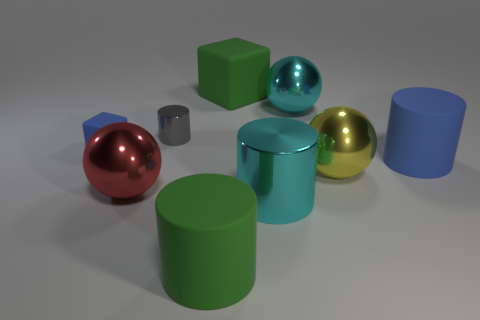There is a blue rubber thing that is right of the tiny cylinder; are there any matte objects that are on the left side of it?
Provide a short and direct response. Yes. What material is the green object that is the same shape as the large blue matte object?
Offer a very short reply. Rubber. Is the number of small cyan metallic balls greater than the number of large yellow things?
Your response must be concise. No. Is the color of the large cube the same as the rubber object that is in front of the yellow thing?
Offer a very short reply. Yes. What color is the big object that is both on the left side of the large metal cylinder and behind the small gray metal thing?
Give a very brief answer. Green. How many other objects are there of the same material as the large yellow object?
Give a very brief answer. 4. Are there fewer green matte cylinders than green rubber balls?
Offer a terse response. No. Is the material of the gray cylinder the same as the thing that is behind the cyan sphere?
Your answer should be compact. No. What shape is the large green object that is in front of the small cylinder?
Provide a succinct answer. Cylinder. Is there anything else that has the same color as the tiny cylinder?
Your answer should be compact. No. 